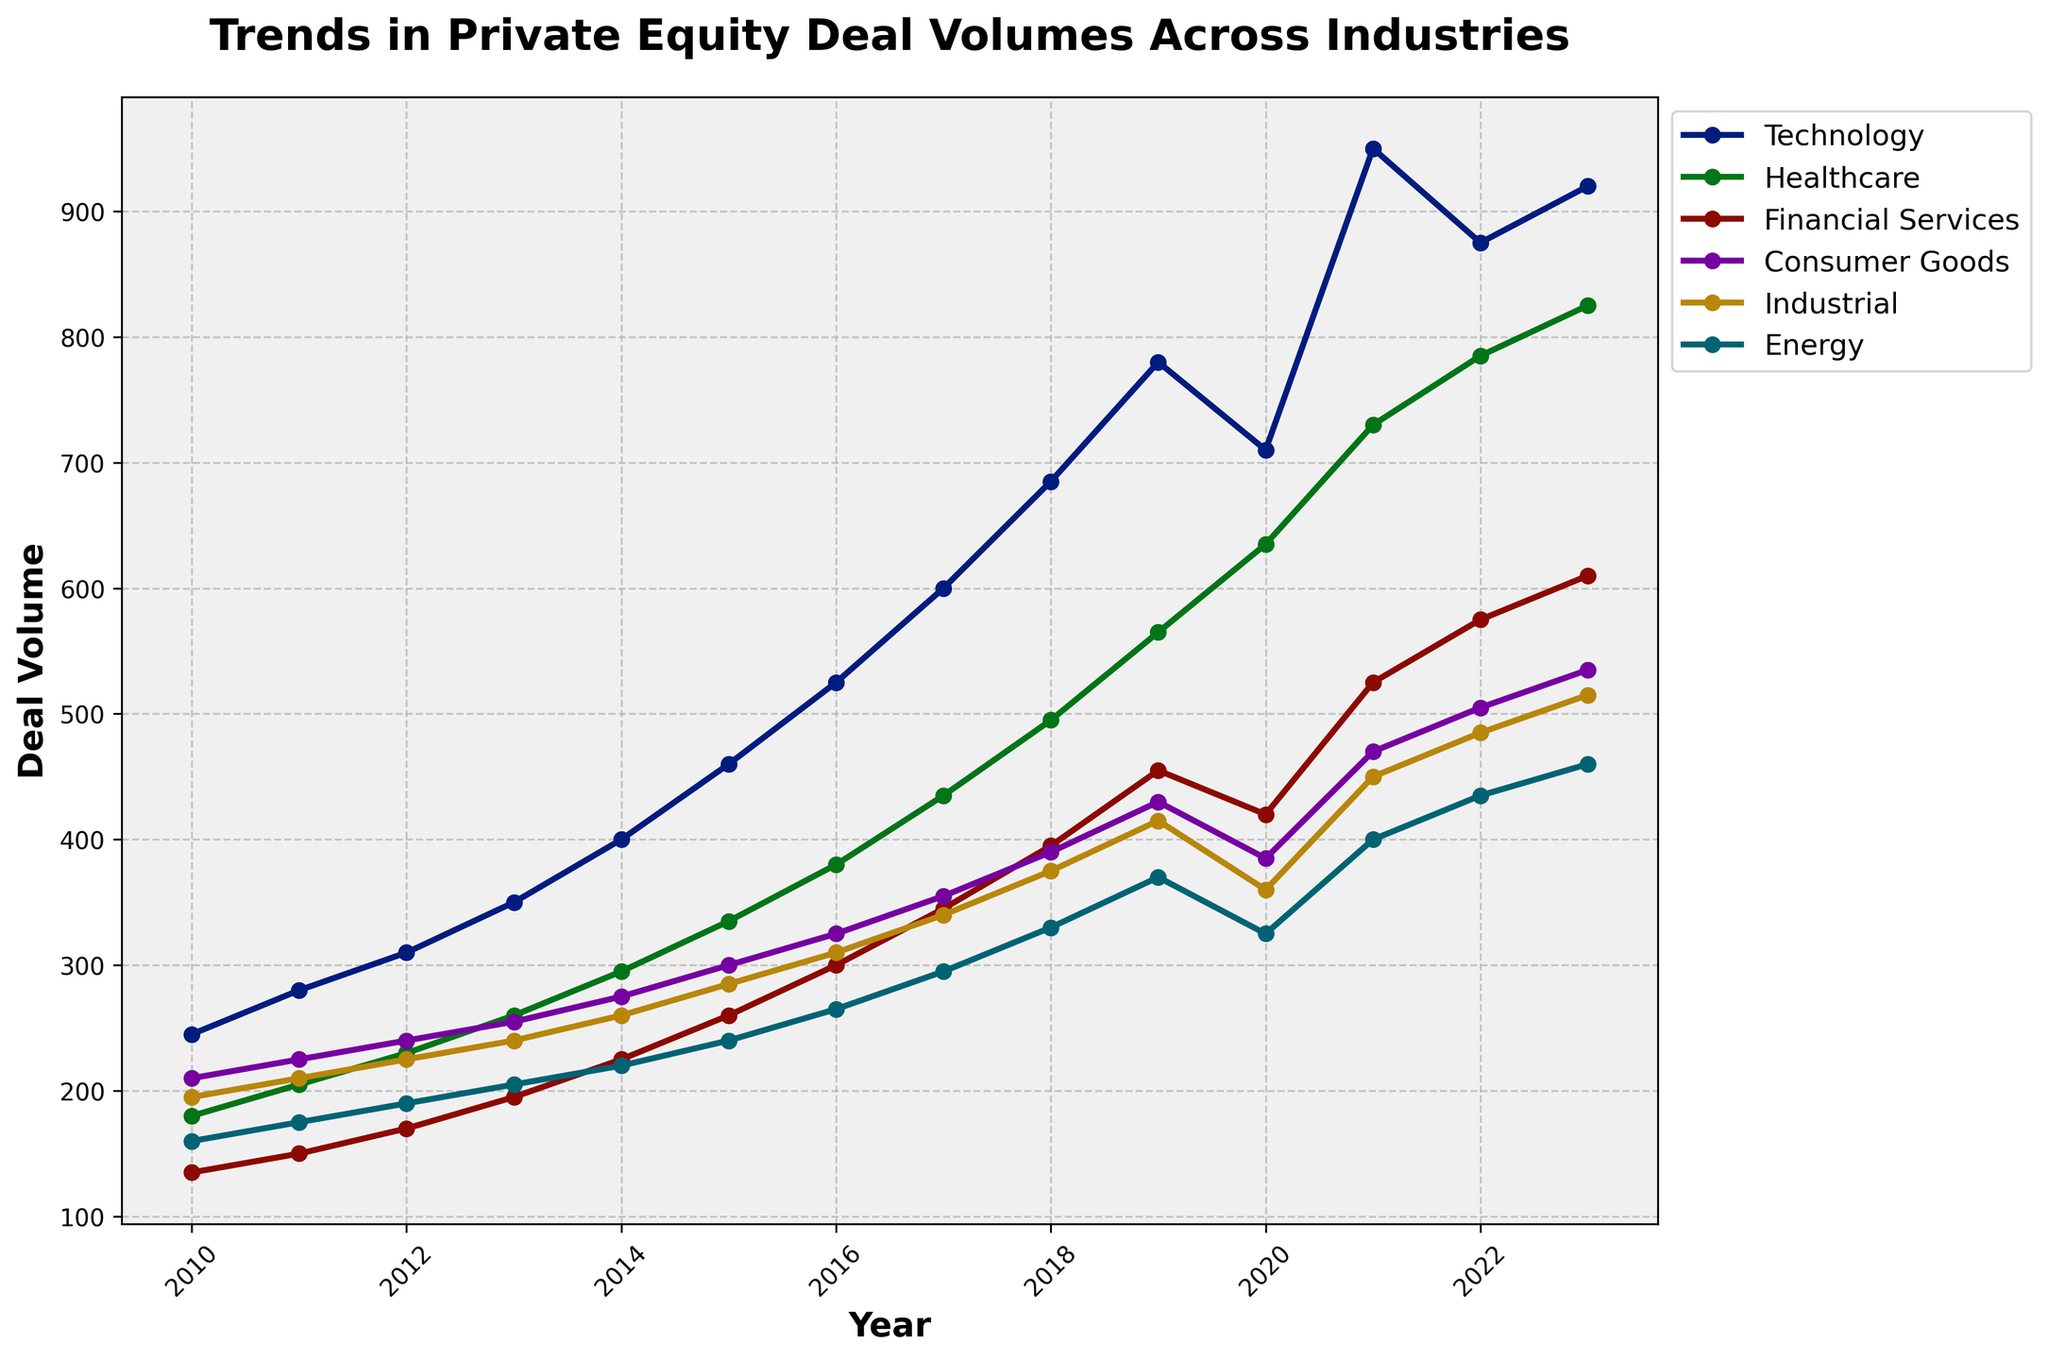Which industry had the highest deal volume in 2023? Look at the endpoint of the lines on the chart for the year 2023 and identify the line that is the highest. The Technology industry line is at the highest position.
Answer: Technology What is the difference in deal volumes between Technology and Healthcare in 2020? Find the points corresponding to Technology and Healthcare for the year 2020. Technology has a deal volume of 710, while Healthcare has a deal volume of 635. Subtract 635 from 710.
Answer: 75 Which two industries showed a similar trend in deal volumes between 2010 and 2023? Observe the lines representing the deal volumes for each industry from 2010 to 2023. The Financial Services and Consumer Goods lines follow similar trends, both rising steadily with minor fluctuations.
Answer: Financial Services and Consumer Goods What is the average deal volume for the Industrial industry from 2010 to 2023? Sum the deal volumes for the Industrial industry from 2010 to 2023 (195 + 210 + 225 + 240 + 260 + 285 + 310 + 340 + 375 + 415 + 360 + 450 + 485 + 515) and then divide by the number of years (14). (4635 / 14)
Answer: 331.07 Between which consecutive years did the Energy industry experience the largest increase in deal volume? Look at the differences in deal volumes for Energy between consecutive years. The largest increase is from 2012 (190) to 2013 (205), which is an increase of 15.
Answer: 2012 to 2013 How did the deal volume in Consumer Goods change between 2015 and 2018? Find the deal volumes for Consumer Goods in 2015 and 2018. In 2015, it was 300, and in 2018, it was 390. Subtract 300 from 390 to find the change.
Answer: Increased by 90 Comparing Energy and Financial Services, which industry had a more significant decline in deal volumes in 2020? Look at the deal volumes for Energy and Financial Services in 2019 and 2020. Energy dropped from 370 to 325 (45 units), and Financial Services dropped from 455 to 420 (35 units). The larger decline is in Energy.
Answer: Energy What is the overall trend for Technology from 2010 to 2023? Observe the Technology line from 2010 to 2023. The line shows a consistent upward trend, indicating increasing deal volumes with minor fluctuations.
Answer: Increasing What was the peak deal volume for Healthcare and in which year did it occur? Look for the highest point on the Healthcare line and note the corresponding year. The peak deal volume for Healthcare is 825 in 2023.
Answer: 825 in 2023 Which industry had the lowest overall variation in deal volumes from 2010 to 2023? Observe the range of deal volumes for each industry across the years. The Energy industry shows the smallest spread between its highest and lowest values, indicating the least variation.
Answer: Energy 